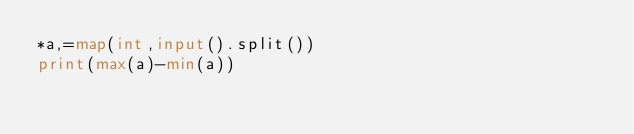Convert code to text. <code><loc_0><loc_0><loc_500><loc_500><_Python_>*a,=map(int,input().split())
print(max(a)-min(a))</code> 